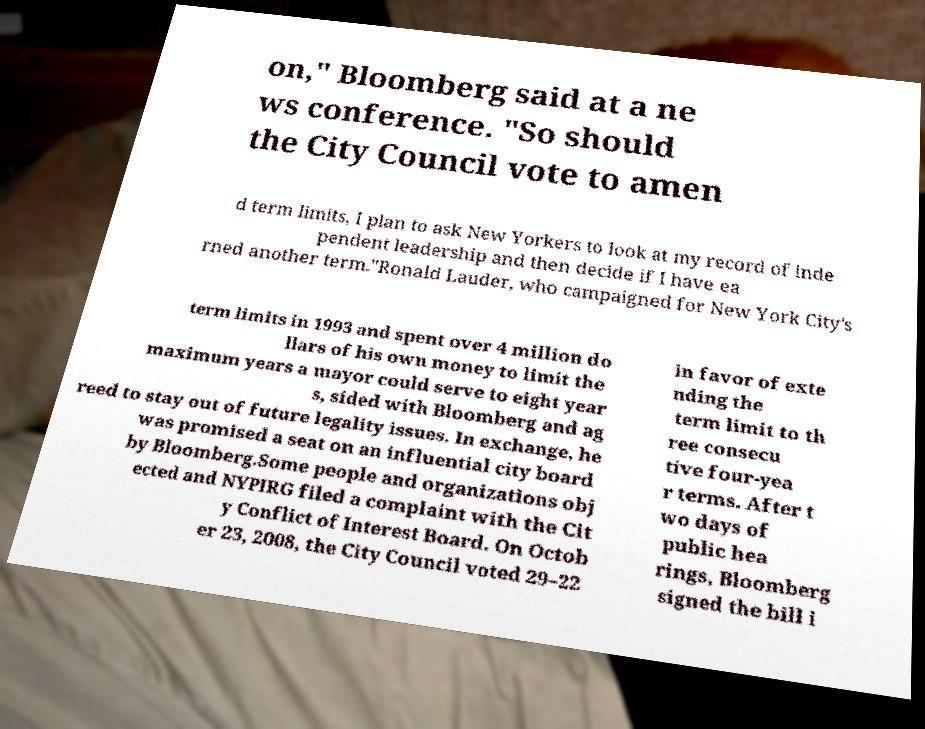There's text embedded in this image that I need extracted. Can you transcribe it verbatim? on," Bloomberg said at a ne ws conference. "So should the City Council vote to amen d term limits, I plan to ask New Yorkers to look at my record of inde pendent leadership and then decide if I have ea rned another term."Ronald Lauder, who campaigned for New York City's term limits in 1993 and spent over 4 million do llars of his own money to limit the maximum years a mayor could serve to eight year s, sided with Bloomberg and ag reed to stay out of future legality issues. In exchange, he was promised a seat on an influential city board by Bloomberg.Some people and organizations obj ected and NYPIRG filed a complaint with the Cit y Conflict of Interest Board. On Octob er 23, 2008, the City Council voted 29–22 in favor of exte nding the term limit to th ree consecu tive four-yea r terms. After t wo days of public hea rings, Bloomberg signed the bill i 